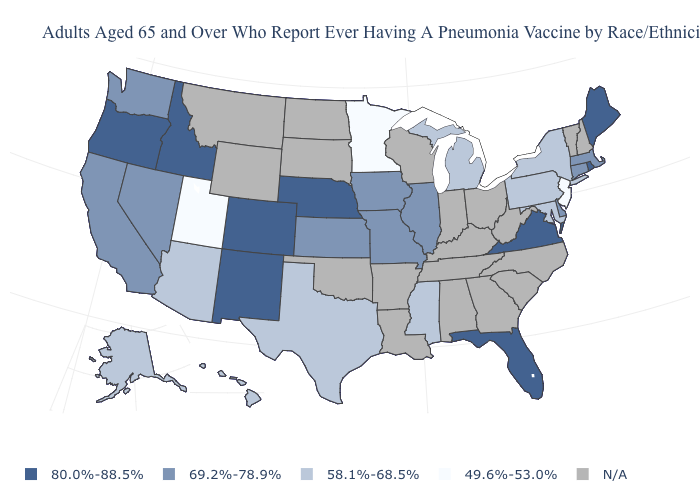What is the value of Alaska?
Concise answer only. 58.1%-68.5%. What is the value of Oregon?
Be succinct. 80.0%-88.5%. Name the states that have a value in the range 80.0%-88.5%?
Quick response, please. Colorado, Florida, Idaho, Maine, Nebraska, New Mexico, Oregon, Rhode Island, Virginia. What is the value of New Mexico?
Be succinct. 80.0%-88.5%. Name the states that have a value in the range 58.1%-68.5%?
Give a very brief answer. Alaska, Arizona, Hawaii, Maryland, Michigan, Mississippi, New York, Pennsylvania, Texas. Name the states that have a value in the range 80.0%-88.5%?
Keep it brief. Colorado, Florida, Idaho, Maine, Nebraska, New Mexico, Oregon, Rhode Island, Virginia. Does New Jersey have the lowest value in the Northeast?
Short answer required. Yes. What is the value of Wyoming?
Short answer required. N/A. What is the value of New Hampshire?
Write a very short answer. N/A. Name the states that have a value in the range 69.2%-78.9%?
Concise answer only. California, Connecticut, Delaware, Illinois, Iowa, Kansas, Massachusetts, Missouri, Nevada, Washington. How many symbols are there in the legend?
Write a very short answer. 5. What is the lowest value in the USA?
Quick response, please. 49.6%-53.0%. What is the value of South Dakota?
Write a very short answer. N/A. Name the states that have a value in the range 49.6%-53.0%?
Concise answer only. Minnesota, New Jersey, Utah. What is the value of West Virginia?
Write a very short answer. N/A. 